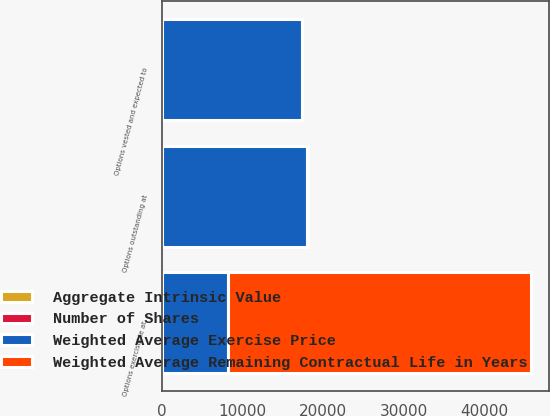<chart> <loc_0><loc_0><loc_500><loc_500><stacked_bar_chart><ecel><fcel>Options outstanding at<fcel>Options exercisable at<fcel>Options vested and expected to<nl><fcel>Weighted Average Exercise Price<fcel>18039<fcel>8141<fcel>17385<nl><fcel>Aggregate Intrinsic Value<fcel>17.4<fcel>18.73<fcel>17.47<nl><fcel>Number of Shares<fcel>4.4<fcel>3.15<fcel>4.33<nl><fcel>Weighted Average Remaining Contractual Life in Years<fcel>18.1<fcel>37574<fcel>18.1<nl></chart> 